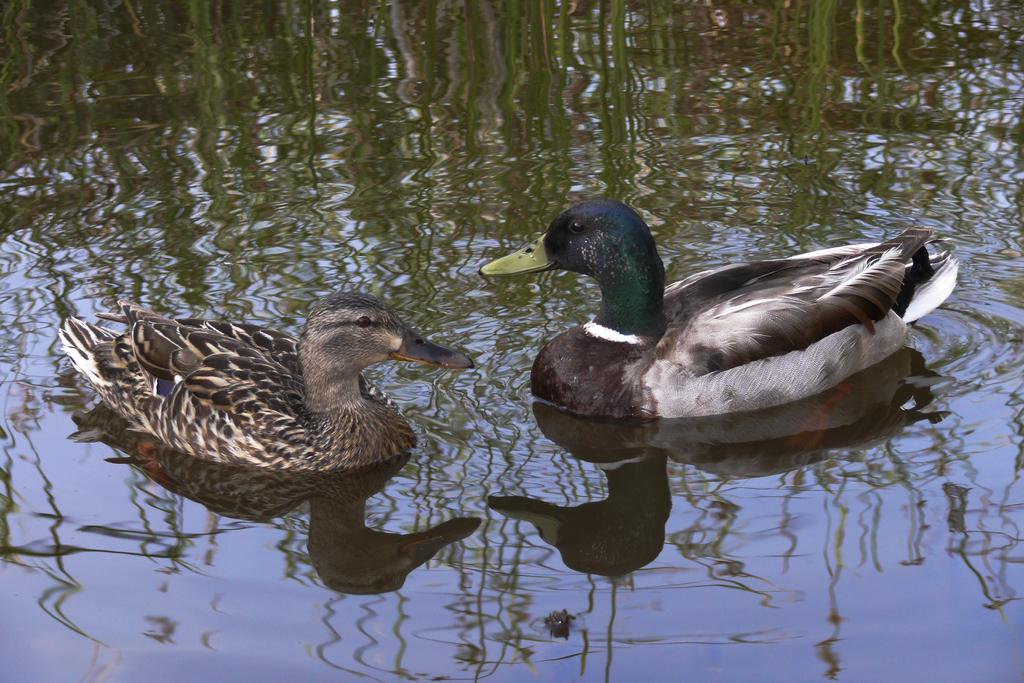What is reflected on the water in the image? There is a reflection of green plants on the water. What type of animals can be seen in the image? Ducks are visible in the image. What type of curve can be seen in the image? There is no curve present in the image. What theory is being demonstrated by the ducks in the image? There is no theory being demonstrated by the ducks in the image. 